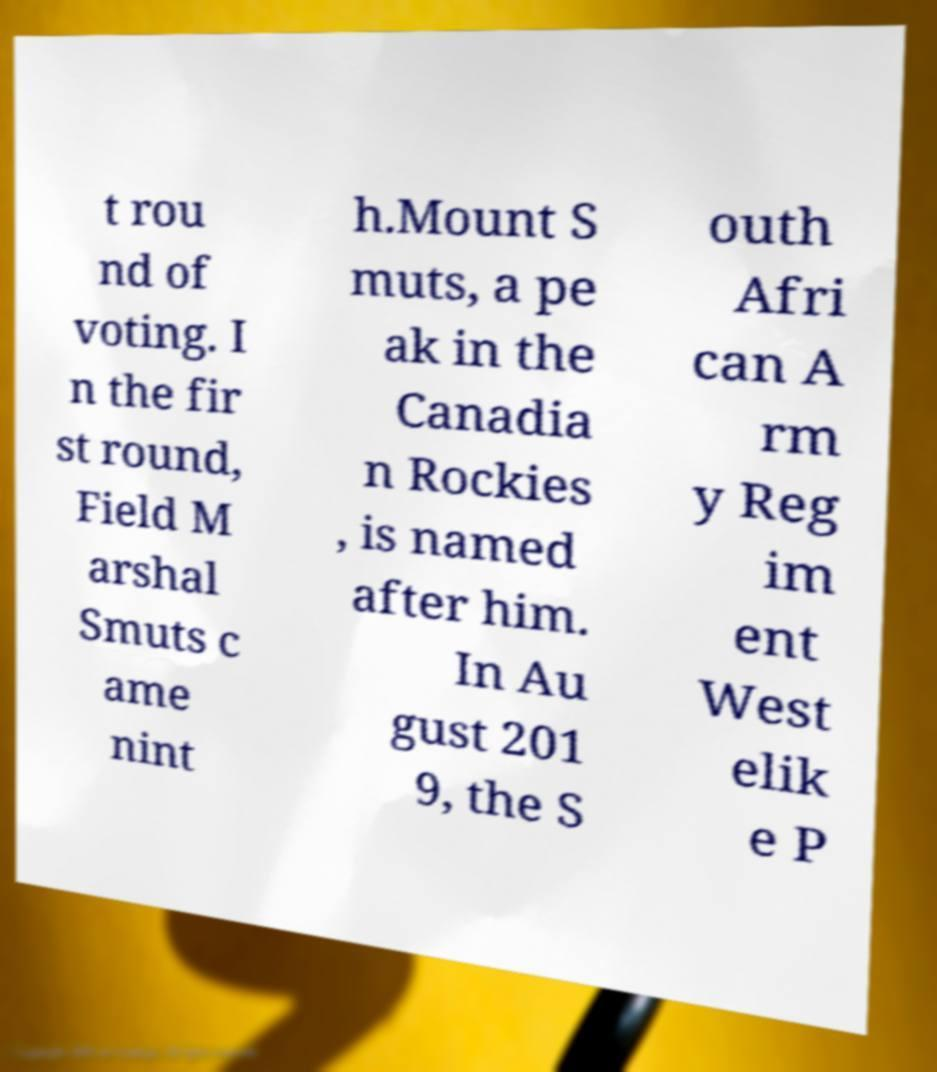There's text embedded in this image that I need extracted. Can you transcribe it verbatim? t rou nd of voting. I n the fir st round, Field M arshal Smuts c ame nint h.Mount S muts, a pe ak in the Canadia n Rockies , is named after him. In Au gust 201 9, the S outh Afri can A rm y Reg im ent West elik e P 